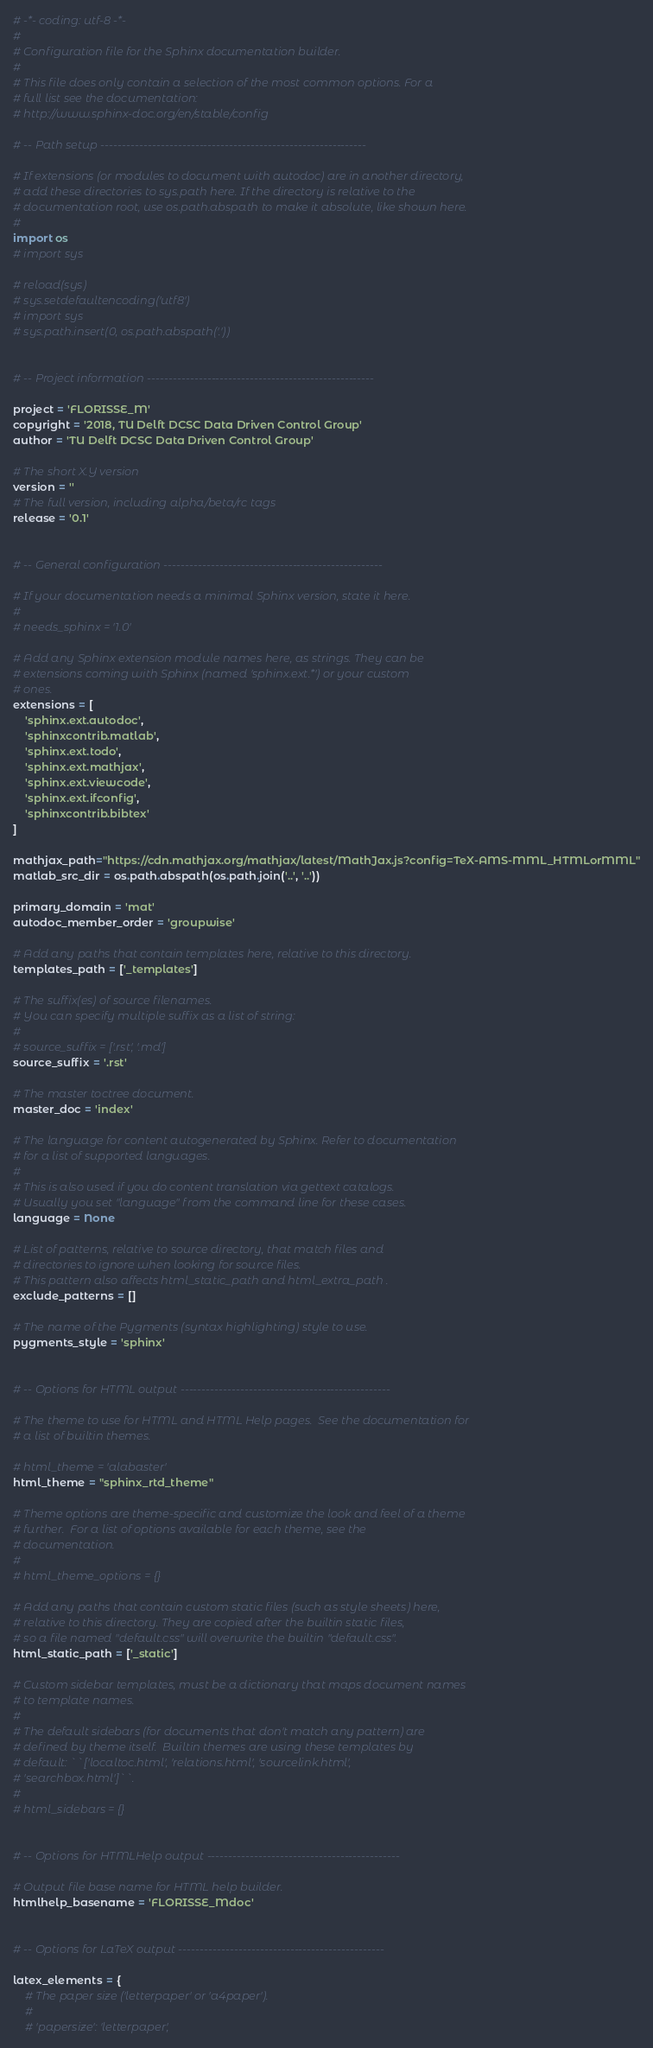<code> <loc_0><loc_0><loc_500><loc_500><_Python_># -*- coding: utf-8 -*-
#
# Configuration file for the Sphinx documentation builder.
#
# This file does only contain a selection of the most common options. For a
# full list see the documentation:
# http://www.sphinx-doc.org/en/stable/config

# -- Path setup --------------------------------------------------------------

# If extensions (or modules to document with autodoc) are in another directory,
# add these directories to sys.path here. If the directory is relative to the
# documentation root, use os.path.abspath to make it absolute, like shown here.
#
import os
# import sys  

# reload(sys)  
# sys.setdefaultencoding('utf8')
# import sys
# sys.path.insert(0, os.path.abspath('.'))


# -- Project information -----------------------------------------------------

project = 'FLORISSE_M'
copyright = '2018, TU Delft DCSC Data Driven Control Group'
author = 'TU Delft DCSC Data Driven Control Group'

# The short X.Y version
version = ''
# The full version, including alpha/beta/rc tags
release = '0.1'


# -- General configuration ---------------------------------------------------

# If your documentation needs a minimal Sphinx version, state it here.
#
# needs_sphinx = '1.0'

# Add any Sphinx extension module names here, as strings. They can be
# extensions coming with Sphinx (named 'sphinx.ext.*') or your custom
# ones.
extensions = [
    'sphinx.ext.autodoc',
    'sphinxcontrib.matlab',
    'sphinx.ext.todo',
    'sphinx.ext.mathjax',
    'sphinx.ext.viewcode',
    'sphinx.ext.ifconfig',
    'sphinxcontrib.bibtex'
]

mathjax_path="https://cdn.mathjax.org/mathjax/latest/MathJax.js?config=TeX-AMS-MML_HTMLorMML"
matlab_src_dir = os.path.abspath(os.path.join('..', '..'))

primary_domain = 'mat'
autodoc_member_order = 'groupwise'

# Add any paths that contain templates here, relative to this directory.
templates_path = ['_templates']

# The suffix(es) of source filenames.
# You can specify multiple suffix as a list of string:
#
# source_suffix = ['.rst', '.md']
source_suffix = '.rst'

# The master toctree document.
master_doc = 'index'

# The language for content autogenerated by Sphinx. Refer to documentation
# for a list of supported languages.
#
# This is also used if you do content translation via gettext catalogs.
# Usually you set "language" from the command line for these cases.
language = None

# List of patterns, relative to source directory, that match files and
# directories to ignore when looking for source files.
# This pattern also affects html_static_path and html_extra_path .
exclude_patterns = []

# The name of the Pygments (syntax highlighting) style to use.
pygments_style = 'sphinx'


# -- Options for HTML output -------------------------------------------------

# The theme to use for HTML and HTML Help pages.  See the documentation for
# a list of builtin themes.

# html_theme = 'alabaster'
html_theme = "sphinx_rtd_theme"

# Theme options are theme-specific and customize the look and feel of a theme
# further.  For a list of options available for each theme, see the
# documentation.
#
# html_theme_options = {}

# Add any paths that contain custom static files (such as style sheets) here,
# relative to this directory. They are copied after the builtin static files,
# so a file named "default.css" will overwrite the builtin "default.css".
html_static_path = ['_static']

# Custom sidebar templates, must be a dictionary that maps document names
# to template names.
#
# The default sidebars (for documents that don't match any pattern) are
# defined by theme itself.  Builtin themes are using these templates by
# default: ``['localtoc.html', 'relations.html', 'sourcelink.html',
# 'searchbox.html']``.
#
# html_sidebars = {}


# -- Options for HTMLHelp output ---------------------------------------------

# Output file base name for HTML help builder.
htmlhelp_basename = 'FLORISSE_Mdoc'


# -- Options for LaTeX output ------------------------------------------------

latex_elements = {
    # The paper size ('letterpaper' or 'a4paper').
    #
    # 'papersize': 'letterpaper',
</code> 